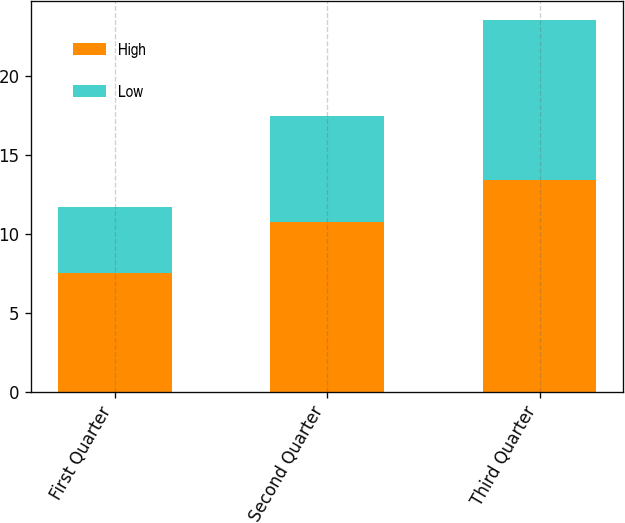<chart> <loc_0><loc_0><loc_500><loc_500><stacked_bar_chart><ecel><fcel>First Quarter<fcel>Second Quarter<fcel>Third Quarter<nl><fcel>High<fcel>7.5<fcel>10.77<fcel>13.43<nl><fcel>Low<fcel>4.19<fcel>6.66<fcel>10.12<nl></chart> 